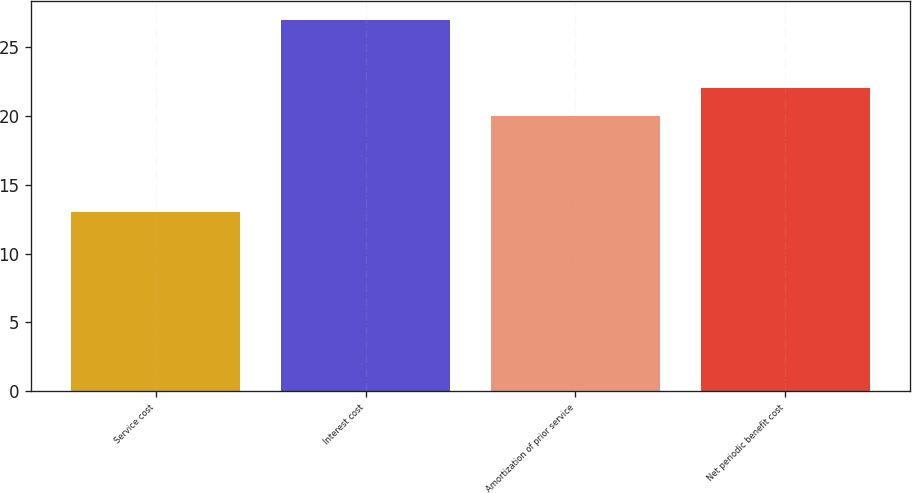<chart> <loc_0><loc_0><loc_500><loc_500><bar_chart><fcel>Service cost<fcel>Interest cost<fcel>Amortization of prior service<fcel>Net periodic benefit cost<nl><fcel>13<fcel>27<fcel>20<fcel>22<nl></chart> 